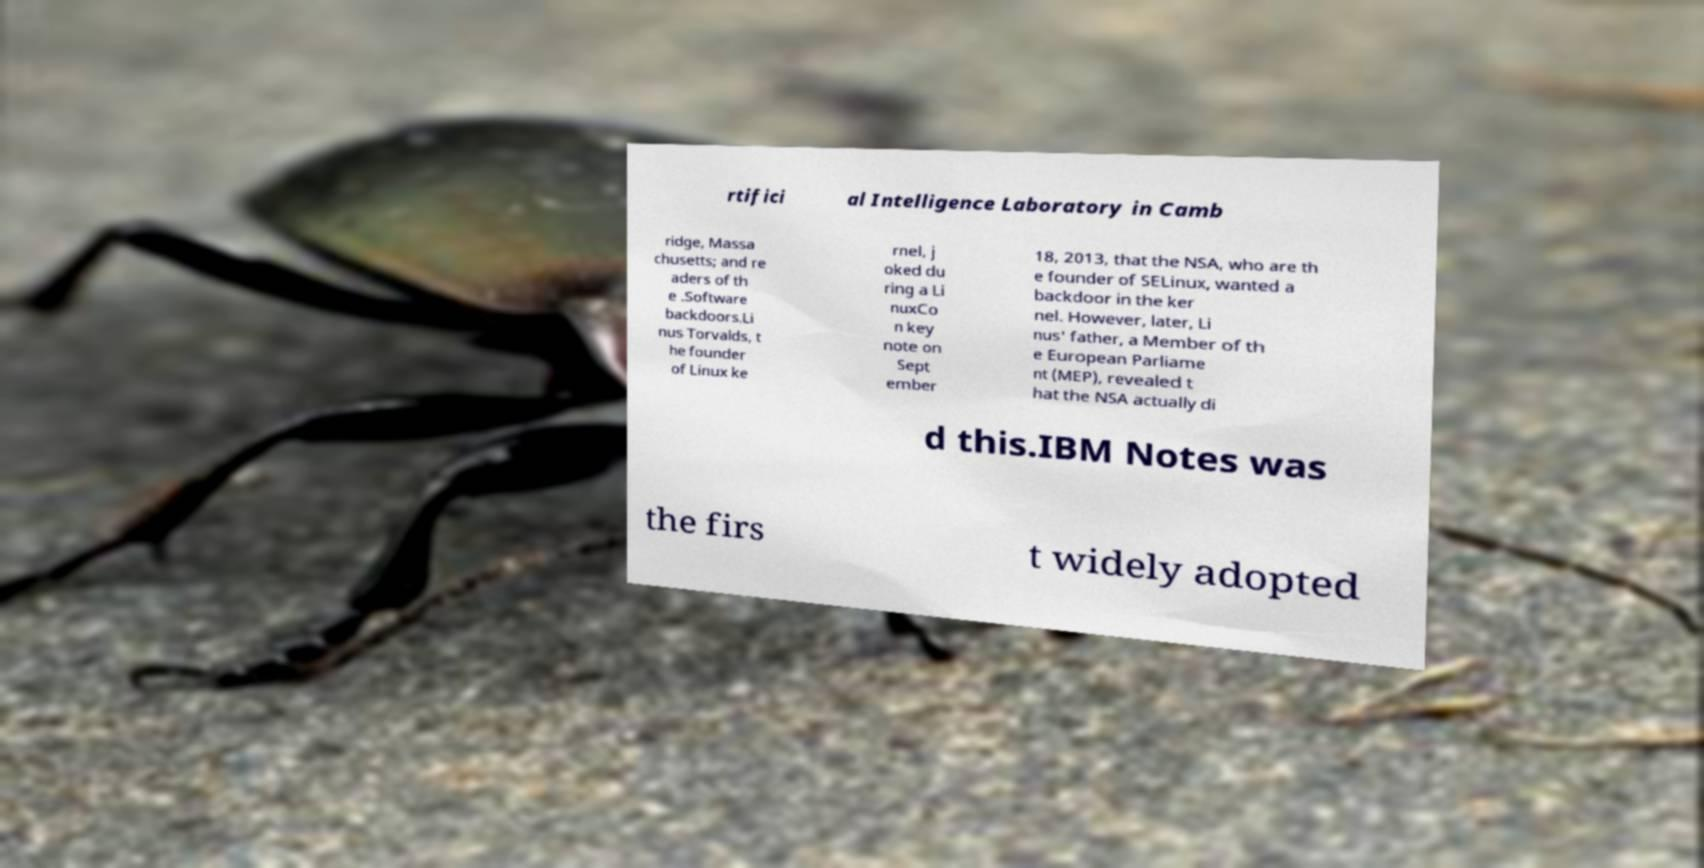Please identify and transcribe the text found in this image. rtifici al Intelligence Laboratory in Camb ridge, Massa chusetts; and re aders of th e .Software backdoors.Li nus Torvalds, t he founder of Linux ke rnel, j oked du ring a Li nuxCo n key note on Sept ember 18, 2013, that the NSA, who are th e founder of SELinux, wanted a backdoor in the ker nel. However, later, Li nus' father, a Member of th e European Parliame nt (MEP), revealed t hat the NSA actually di d this.IBM Notes was the firs t widely adopted 